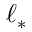<formula> <loc_0><loc_0><loc_500><loc_500>\ell _ { * }</formula> 